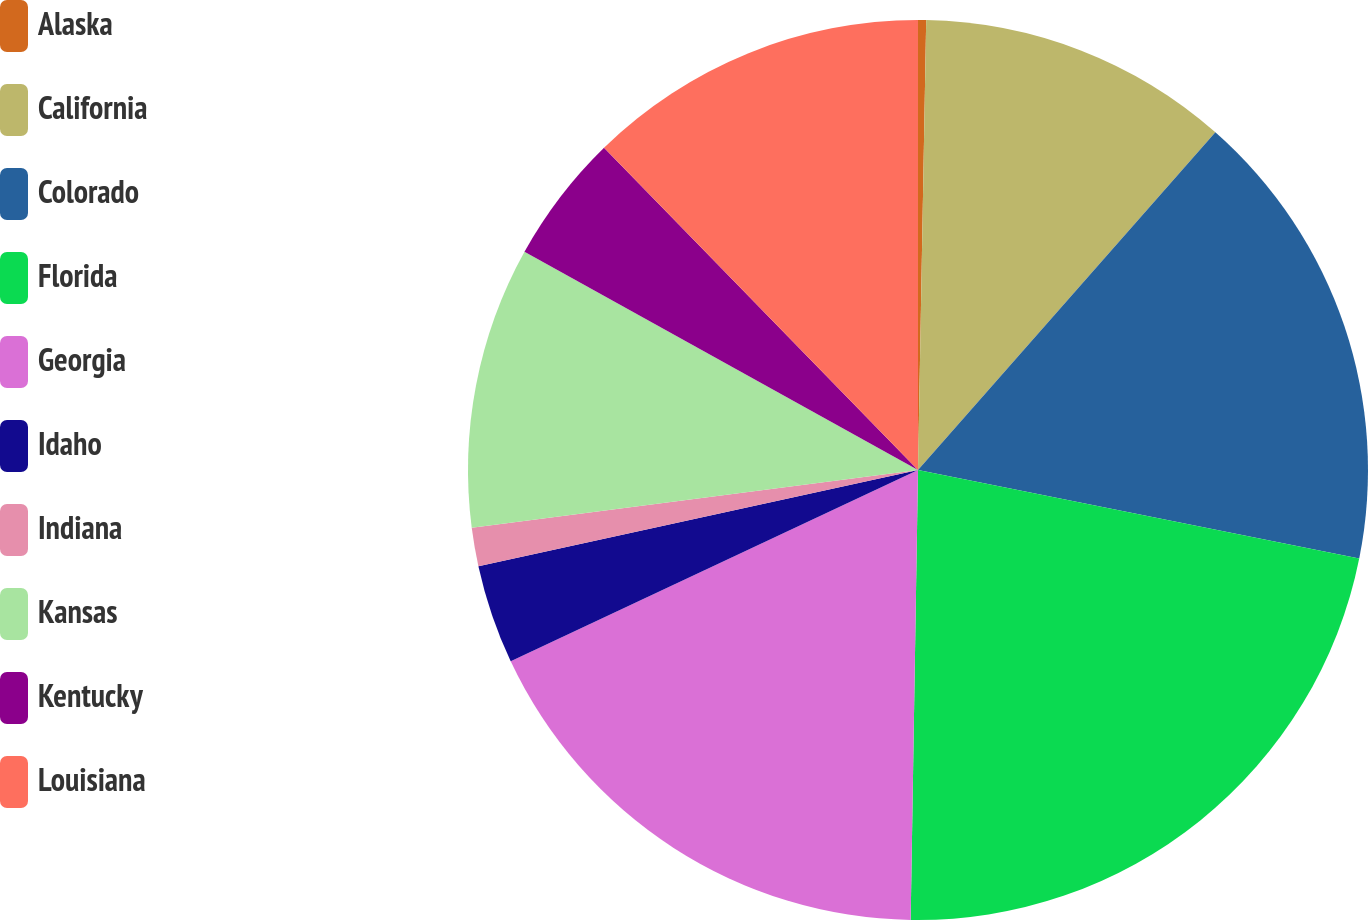Convert chart to OTSL. <chart><loc_0><loc_0><loc_500><loc_500><pie_chart><fcel>Alaska<fcel>California<fcel>Colorado<fcel>Florida<fcel>Georgia<fcel>Idaho<fcel>Indiana<fcel>Kansas<fcel>Kentucky<fcel>Louisiana<nl><fcel>0.29%<fcel>11.2%<fcel>16.66%<fcel>22.11%<fcel>17.75%<fcel>3.56%<fcel>1.38%<fcel>10.11%<fcel>4.65%<fcel>12.29%<nl></chart> 